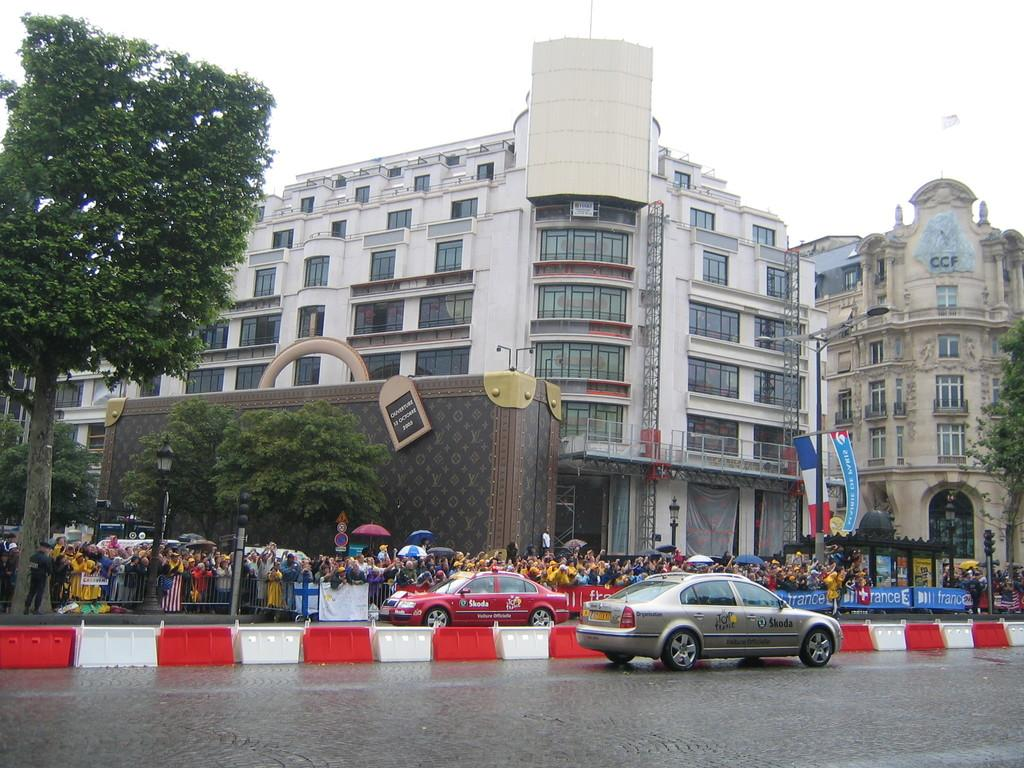<image>
Present a compact description of the photo's key features. Car that is on the side of a road that says Skoda on it; And a Red car on the other side that says Skoda on it. 